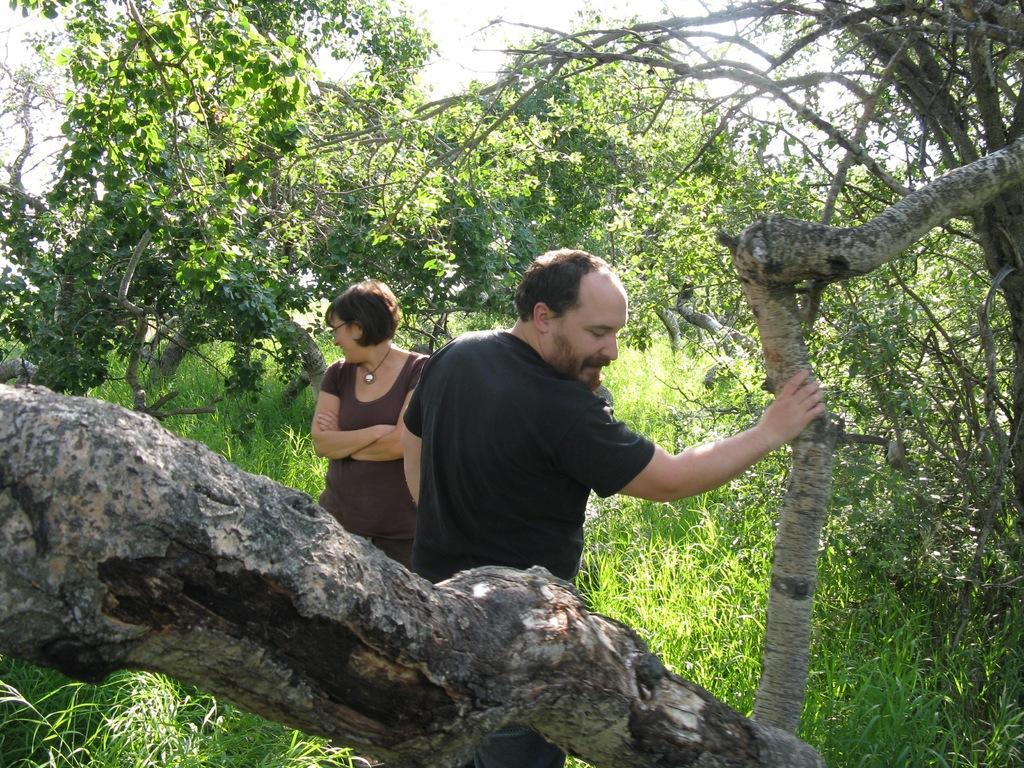Can you describe this image briefly? In this image, I can see two persons standing. There are trees and grass. In the background, there is the sky. 